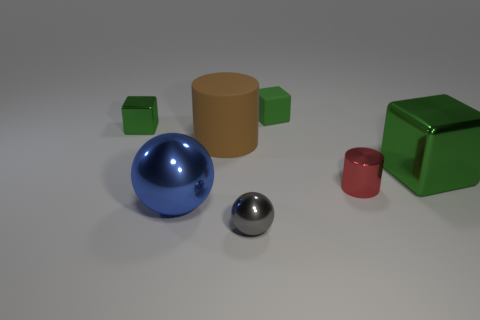What is the size of the red cylinder that is the same material as the gray object?
Provide a short and direct response. Small. What number of gray metallic things are the same shape as the red shiny thing?
Ensure brevity in your answer.  0. Is the number of red objects behind the big metallic block greater than the number of large matte cylinders?
Give a very brief answer. No. What is the shape of the shiny thing that is behind the tiny red metallic thing and left of the gray object?
Give a very brief answer. Cube. Does the gray thing have the same size as the blue metal thing?
Offer a very short reply. No. There is a tiny green rubber cube; how many big green things are to the left of it?
Ensure brevity in your answer.  0. Is the number of big blue metallic things that are right of the large rubber object the same as the number of brown objects that are to the right of the tiny gray shiny object?
Your answer should be very brief. Yes. Does the matte thing that is to the right of the brown thing have the same shape as the blue thing?
Offer a very short reply. No. Is there any other thing that has the same material as the brown thing?
Offer a terse response. Yes. There is a red object; does it have the same size as the block left of the gray ball?
Give a very brief answer. Yes. 